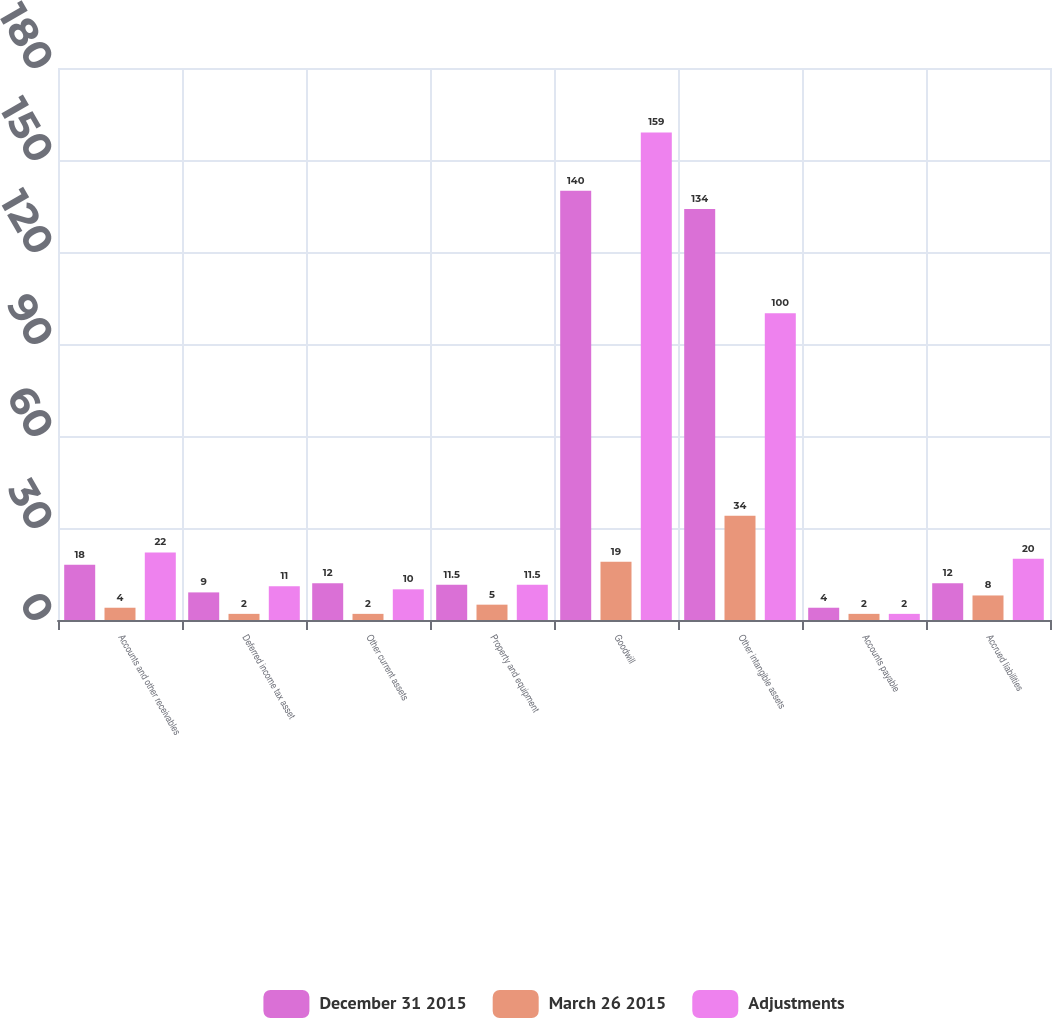<chart> <loc_0><loc_0><loc_500><loc_500><stacked_bar_chart><ecel><fcel>Accounts and other receivables<fcel>Deferred income tax asset<fcel>Other current assets<fcel>Property and equipment<fcel>Goodwill<fcel>Other intangible assets<fcel>Accounts payable<fcel>Accrued liabilities<nl><fcel>December 31 2015<fcel>18<fcel>9<fcel>12<fcel>11.5<fcel>140<fcel>134<fcel>4<fcel>12<nl><fcel>March 26 2015<fcel>4<fcel>2<fcel>2<fcel>5<fcel>19<fcel>34<fcel>2<fcel>8<nl><fcel>Adjustments<fcel>22<fcel>11<fcel>10<fcel>11.5<fcel>159<fcel>100<fcel>2<fcel>20<nl></chart> 